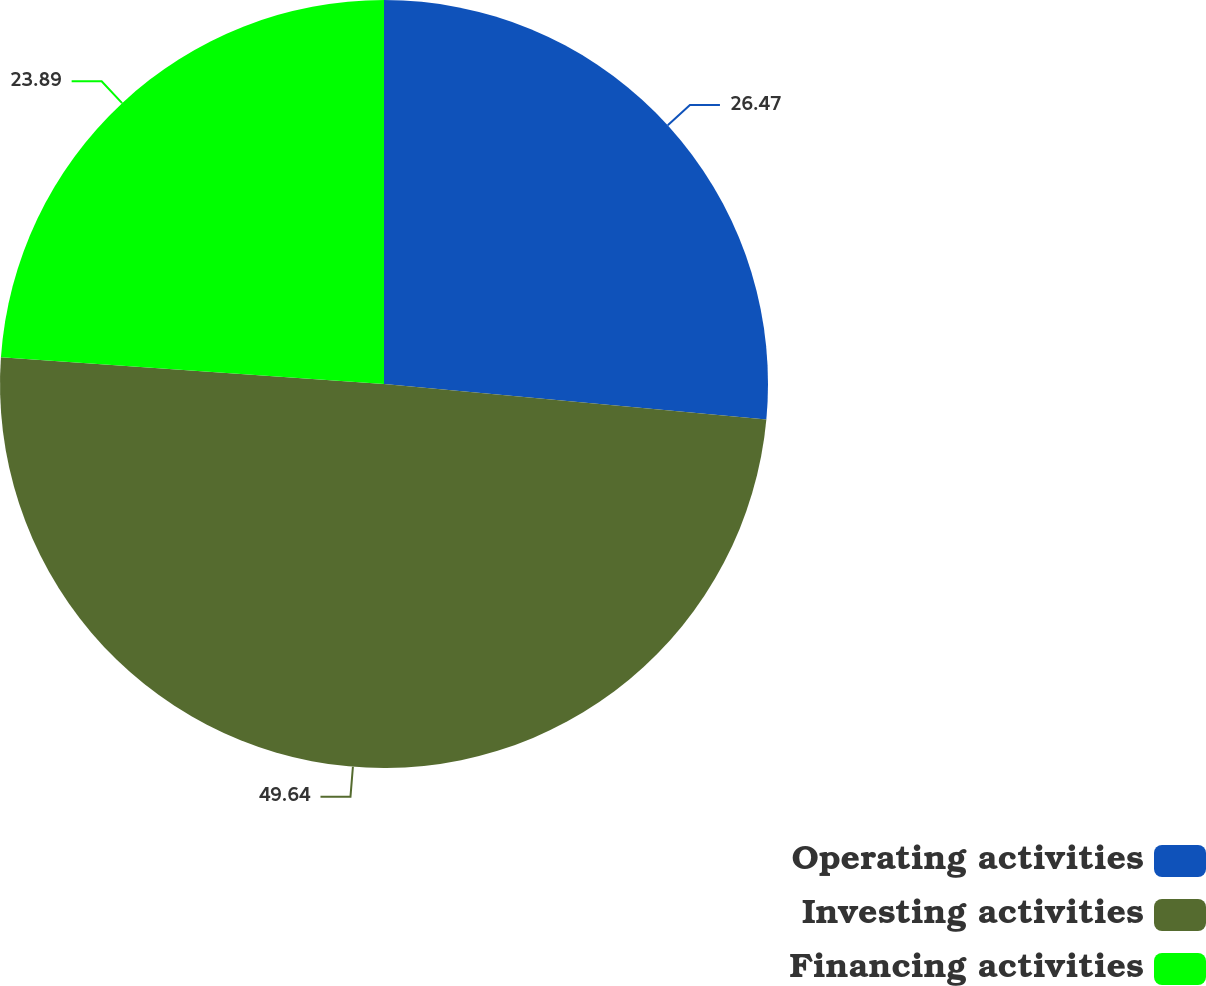Convert chart. <chart><loc_0><loc_0><loc_500><loc_500><pie_chart><fcel>Operating activities<fcel>Investing activities<fcel>Financing activities<nl><fcel>26.47%<fcel>49.64%<fcel>23.89%<nl></chart> 